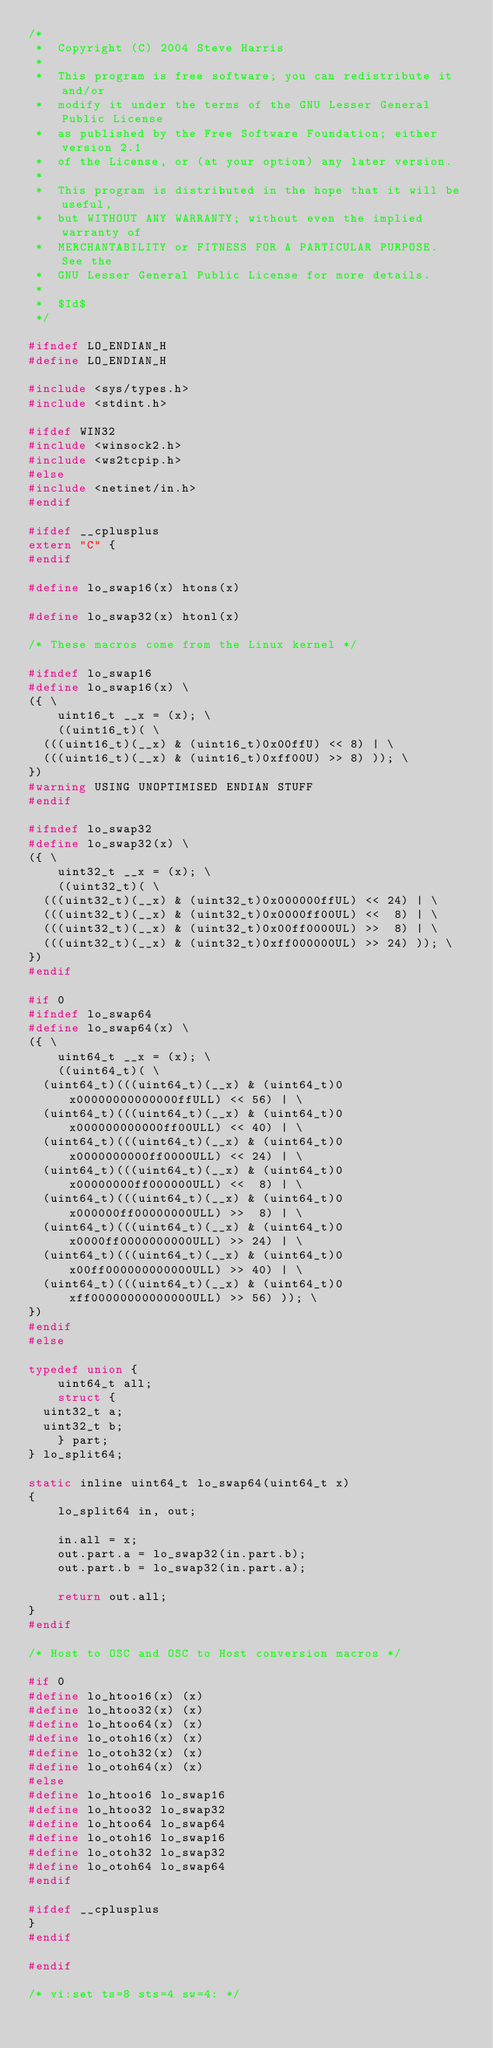Convert code to text. <code><loc_0><loc_0><loc_500><loc_500><_C_>/*
 *  Copyright (C) 2004 Steve Harris
 *
 *  This program is free software; you can redistribute it and/or
 *  modify it under the terms of the GNU Lesser General Public License
 *  as published by the Free Software Foundation; either version 2.1
 *  of the License, or (at your option) any later version.
 *
 *  This program is distributed in the hope that it will be useful,
 *  but WITHOUT ANY WARRANTY; without even the implied warranty of
 *  MERCHANTABILITY or FITNESS FOR A PARTICULAR PURPOSE.  See the
 *  GNU Lesser General Public License for more details.
 *
 *  $Id$
 */

#ifndef LO_ENDIAN_H
#define LO_ENDIAN_H

#include <sys/types.h>
#include <stdint.h>

#ifdef WIN32
#include <winsock2.h>
#include <ws2tcpip.h>
#else
#include <netinet/in.h>
#endif

#ifdef __cplusplus
extern "C" {
#endif

#define lo_swap16(x) htons(x)

#define lo_swap32(x) htonl(x)

/* These macros come from the Linux kernel */

#ifndef lo_swap16
#define lo_swap16(x) \
({ \
    uint16_t __x = (x); \
    ((uint16_t)( \
	(((uint16_t)(__x) & (uint16_t)0x00ffU) << 8) | \
	(((uint16_t)(__x) & (uint16_t)0xff00U) >> 8) )); \
})
#warning USING UNOPTIMISED ENDIAN STUFF
#endif

#ifndef lo_swap32
#define lo_swap32(x) \
({ \
    uint32_t __x = (x); \
    ((uint32_t)( \
	(((uint32_t)(__x) & (uint32_t)0x000000ffUL) << 24) | \
	(((uint32_t)(__x) & (uint32_t)0x0000ff00UL) <<  8) | \
	(((uint32_t)(__x) & (uint32_t)0x00ff0000UL) >>  8) | \
	(((uint32_t)(__x) & (uint32_t)0xff000000UL) >> 24) )); \
})
#endif

#if 0
#ifndef lo_swap64
#define lo_swap64(x) \
({ \
    uint64_t __x = (x); \
    ((uint64_t)( \
	(uint64_t)(((uint64_t)(__x) & (uint64_t)0x00000000000000ffULL) << 56) | \
	(uint64_t)(((uint64_t)(__x) & (uint64_t)0x000000000000ff00ULL) << 40) | \
	(uint64_t)(((uint64_t)(__x) & (uint64_t)0x0000000000ff0000ULL) << 24) | \
	(uint64_t)(((uint64_t)(__x) & (uint64_t)0x00000000ff000000ULL) <<  8) | \
	(uint64_t)(((uint64_t)(__x) & (uint64_t)0x000000ff00000000ULL) >>  8) | \
	(uint64_t)(((uint64_t)(__x) & (uint64_t)0x0000ff0000000000ULL) >> 24) | \
	(uint64_t)(((uint64_t)(__x) & (uint64_t)0x00ff000000000000ULL) >> 40) | \
	(uint64_t)(((uint64_t)(__x) & (uint64_t)0xff00000000000000ULL) >> 56) )); \
})
#endif
#else

typedef union {
    uint64_t all;
    struct {
	uint32_t a;
	uint32_t b;
    } part;
} lo_split64;

static inline uint64_t lo_swap64(uint64_t x)
{
    lo_split64 in, out;

    in.all = x;
    out.part.a = lo_swap32(in.part.b);
    out.part.b = lo_swap32(in.part.a);

    return out.all;
}
#endif

/* Host to OSC and OSC to Host conversion macros */

#if 0
#define lo_htoo16(x) (x)
#define lo_htoo32(x) (x)
#define lo_htoo64(x) (x)
#define lo_otoh16(x) (x)
#define lo_otoh32(x) (x)
#define lo_otoh64(x) (x)
#else
#define lo_htoo16 lo_swap16
#define lo_htoo32 lo_swap32
#define lo_htoo64 lo_swap64
#define lo_otoh16 lo_swap16
#define lo_otoh32 lo_swap32
#define lo_otoh64 lo_swap64
#endif

#ifdef __cplusplus
}
#endif

#endif

/* vi:set ts=8 sts=4 sw=4: */
</code> 